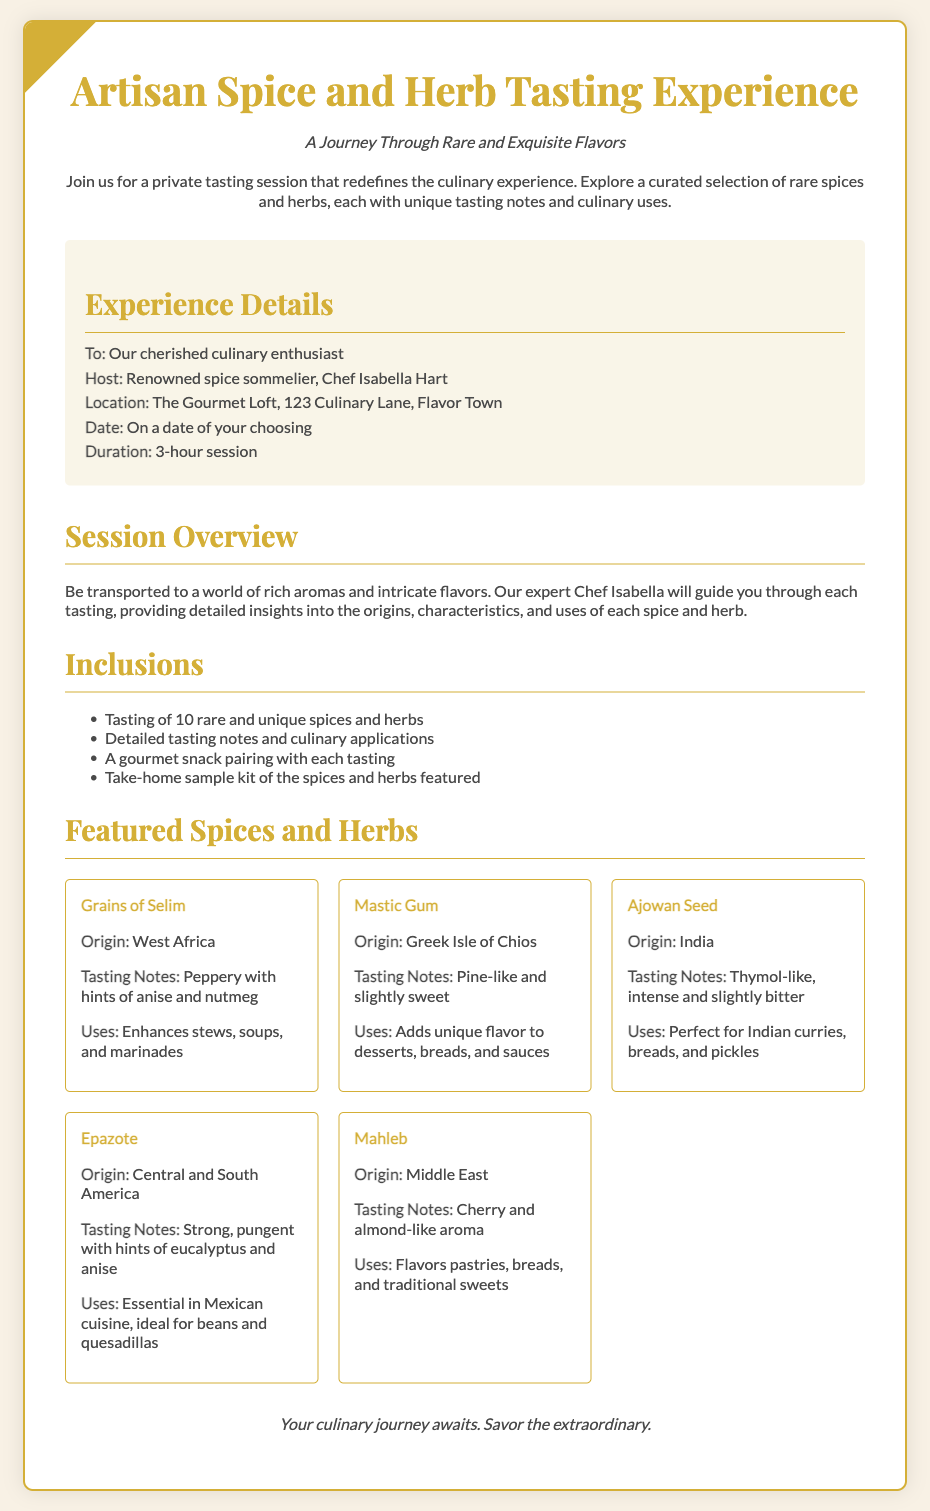what is the title of the experience? The title of the experience is prominently displayed at the top of the document.
Answer: Artisan Spice and Herb Tasting Experience who is the host of the experience? The document mentions the host in the details section.
Answer: Chef Isabella Hart what is the location of the tasting session? The location is listed under experience details in the document.
Answer: The Gourmet Loft, 123 Culinary Lane, Flavor Town how long is the duration of the session? The duration is specifically mentioned in the experience details section of the document.
Answer: 3-hour session how many rare spices and herbs will be tasted? The number of spices and herbs is indicated in the inclusions list.
Answer: 10 which spice is of Greek origin? The origin of each spice can be found under the featured spices and herbs section.
Answer: Mastic Gum what unique flavor does Epazote add to dishes? The uses of Epazote are detailed in the spice item section.
Answer: Mexican cuisine what culinary application is suggested for Ajowan Seed? The uses section for Ajowan Seed specifies its culinary applications.
Answer: Indian curries what is provided as a takeaway from the tasting experience? The inclusions section lists what participants can take home after the session.
Answer: Take-home sample kit of the spices and herbs featured 